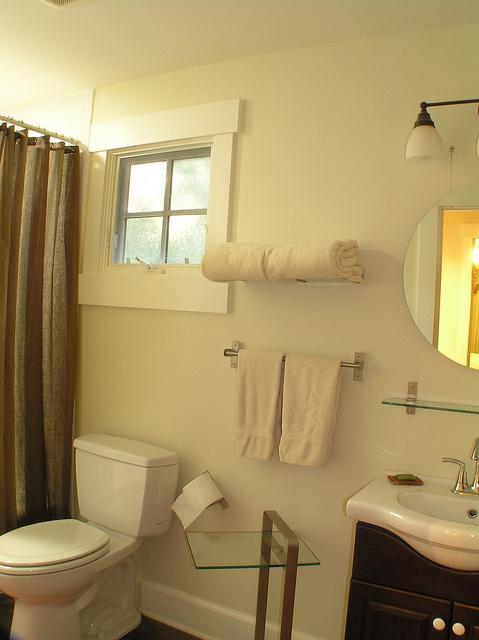What color is the bar of soap on the sink?
Be succinct. Green. How many robes are hanging up?
Write a very short answer. 0. How are the walls painted?
Give a very brief answer. White. Is this a modern bathroom?
Be succinct. Yes. Where is the toilet paper?
Write a very short answer. On wall. Does the toilet have a standard or extended seat?
Answer briefly. Standard. 